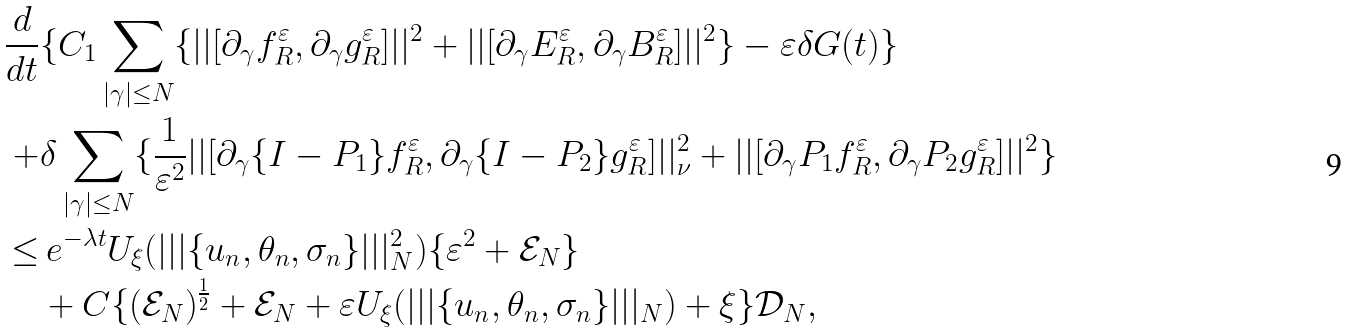<formula> <loc_0><loc_0><loc_500><loc_500>\frac { d } { d t } & \{ C _ { 1 } \sum _ { | \gamma | \leq N } \{ | | [ \partial _ { \gamma } { f _ { R } ^ { \varepsilon } } , \partial _ { \gamma } { g _ { R } ^ { \varepsilon } } ] | | ^ { 2 } + | | [ \partial _ { \gamma } E _ { R } ^ { \varepsilon } , \partial _ { \gamma } B _ { R } ^ { \varepsilon } ] | | ^ { 2 } \} - \varepsilon \delta G ( t ) \} \\ + & \delta \sum _ { | \gamma | \leq N } \{ \frac { 1 } { \varepsilon ^ { 2 } } | | [ \partial _ { \gamma } { \{ I - P _ { 1 } \} f _ { R } ^ { \varepsilon } } , \partial _ { \gamma } { \{ I - P _ { 2 } \} g _ { R } ^ { \varepsilon } } ] | | _ { \nu } ^ { 2 } + | | [ \partial _ { \gamma } { P _ { 1 } f _ { R } ^ { \varepsilon } } , \partial _ { \gamma } { P _ { 2 } g _ { R } ^ { \varepsilon } } ] | | ^ { 2 } \} \\ \leq & \, e ^ { - \lambda t } U _ { \xi } ( | | | \{ u _ { n } , \theta _ { n } , \sigma _ { n } \} | | | _ { N } ^ { 2 } ) \{ \varepsilon ^ { 2 } + \mathcal { E } _ { N } \} \\ & + C \{ ( \mathcal { E } _ { N } ) ^ { \frac { 1 } { 2 } } + \mathcal { E } _ { N } + \varepsilon U _ { \xi } ( | | | \{ u _ { n } , \theta _ { n } , \sigma _ { n } \} | | | _ { N } ) + \xi \} \mathcal { D } _ { N } ,</formula> 